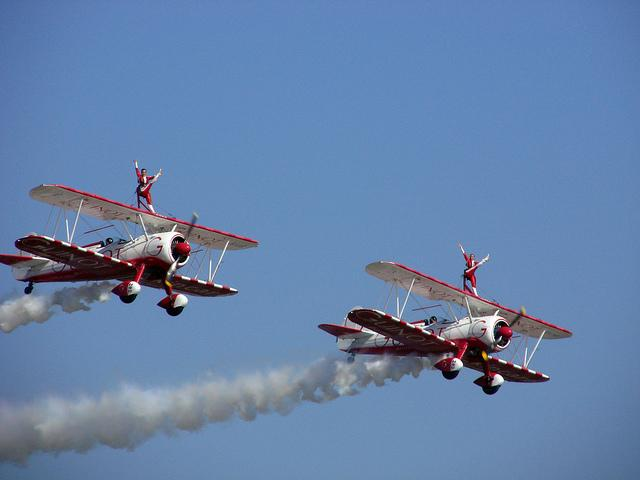What profession do the people on top of the planes belong to? acrobats 